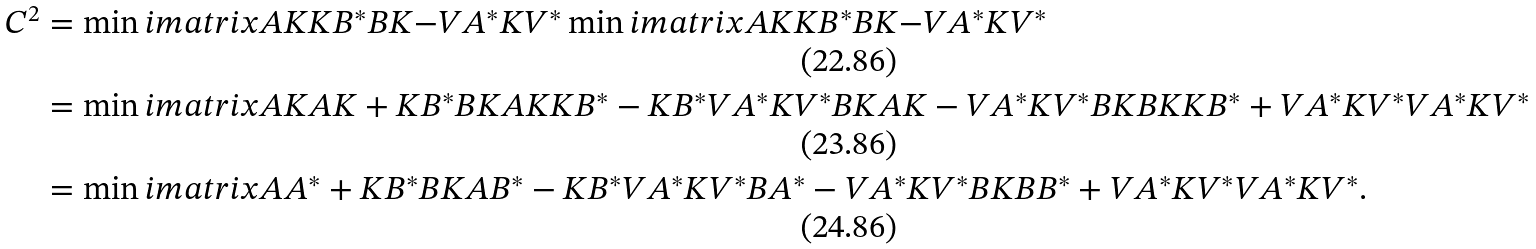Convert formula to latex. <formula><loc_0><loc_0><loc_500><loc_500>C ^ { 2 } & = \min i m a t r i x { A K } { K B ^ { * } } { B K } { - V A ^ { * } K V ^ { * } } \min i m a t r i x { A K } { K B ^ { * } } { B K } { - V A ^ { * } K V ^ { * } } \\ & = \min i m a t r i x { A K A K + K B ^ { * } B K } { A K K B ^ { * } - K B ^ { * } V A ^ { * } K V ^ { * } } { B K A K - V A ^ { * } K V ^ { * } B K } { B K K B ^ { * } + V A ^ { * } K V ^ { * } V A ^ { * } K V ^ { * } } \\ & = \min i m a t r i x { A A ^ { * } + K B ^ { * } B K } { A B ^ { * } - K B ^ { * } V A ^ { * } K V ^ { * } } { B A ^ { * } - V A ^ { * } K V ^ { * } B K } { B B ^ { * } + V A ^ { * } K V ^ { * } V A ^ { * } K V ^ { * } } .</formula> 